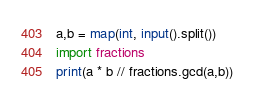<code> <loc_0><loc_0><loc_500><loc_500><_Python_>a,b = map(int, input().split())
import fractions
print(a * b // fractions.gcd(a,b))</code> 